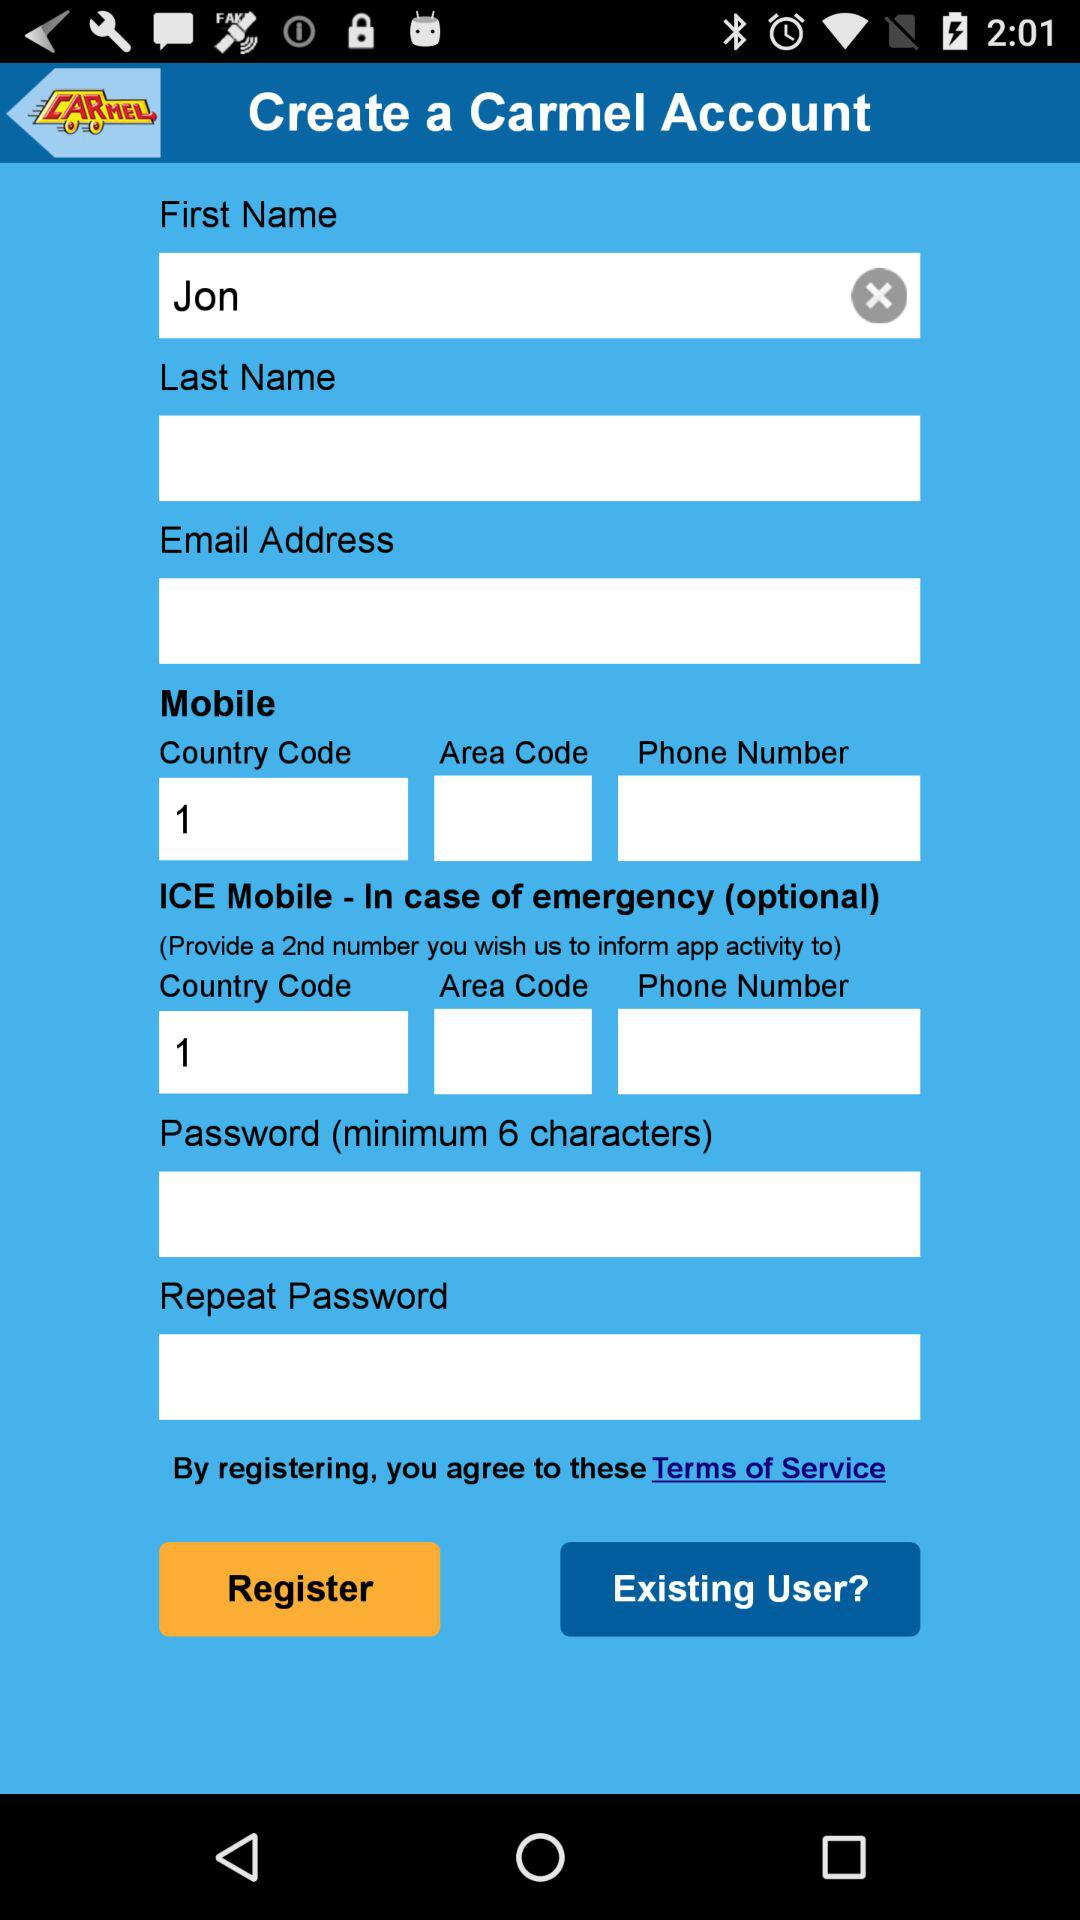What is the first name? The first name is Jon. 